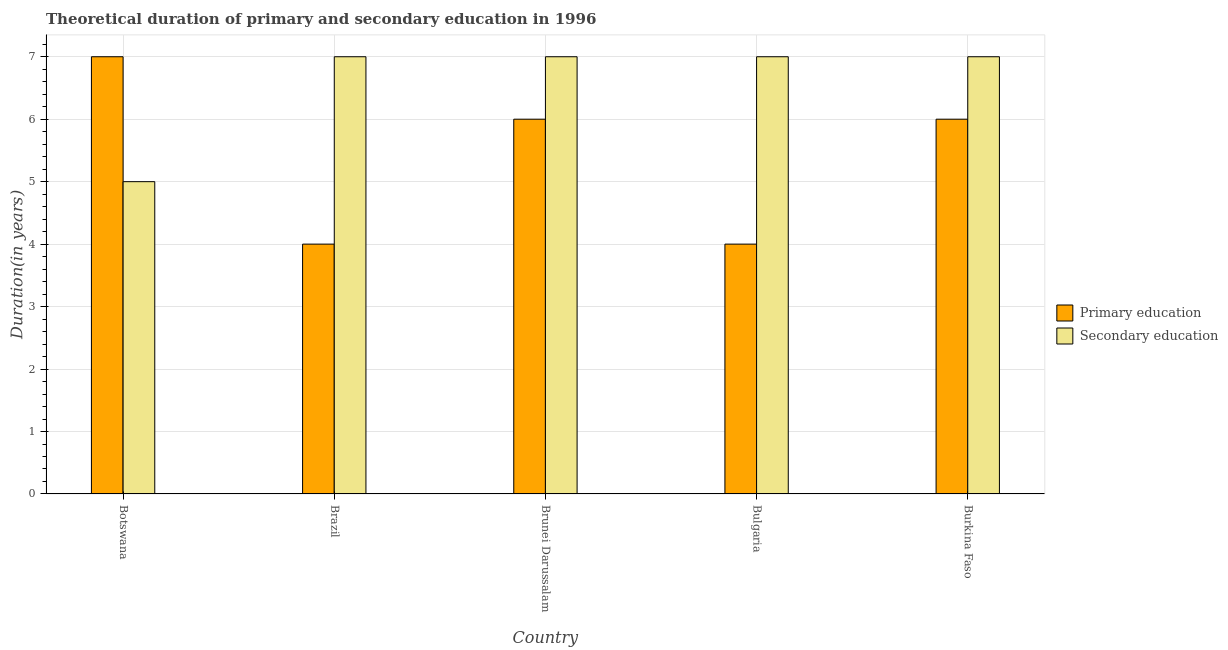How many different coloured bars are there?
Your answer should be compact. 2. How many groups of bars are there?
Ensure brevity in your answer.  5. Are the number of bars per tick equal to the number of legend labels?
Provide a succinct answer. Yes. How many bars are there on the 5th tick from the right?
Ensure brevity in your answer.  2. In how many cases, is the number of bars for a given country not equal to the number of legend labels?
Offer a very short reply. 0. What is the duration of primary education in Botswana?
Give a very brief answer. 7. Across all countries, what is the maximum duration of secondary education?
Ensure brevity in your answer.  7. Across all countries, what is the minimum duration of primary education?
Provide a short and direct response. 4. In which country was the duration of secondary education maximum?
Your answer should be very brief. Brazil. What is the total duration of secondary education in the graph?
Keep it short and to the point. 33. What is the difference between the duration of secondary education in Brazil and that in Bulgaria?
Make the answer very short. 0. What is the difference between the duration of primary education in Burkina Faso and the duration of secondary education in Bulgaria?
Your answer should be compact. -1. What is the average duration of secondary education per country?
Your answer should be compact. 6.6. What is the difference between the duration of secondary education and duration of primary education in Botswana?
Your response must be concise. -2. In how many countries, is the duration of secondary education greater than 1 years?
Your answer should be very brief. 5. What is the ratio of the duration of secondary education in Brunei Darussalam to that in Burkina Faso?
Provide a succinct answer. 1. What is the difference between the highest and the lowest duration of primary education?
Give a very brief answer. 3. Is the sum of the duration of primary education in Brazil and Brunei Darussalam greater than the maximum duration of secondary education across all countries?
Make the answer very short. Yes. What does the 2nd bar from the left in Brunei Darussalam represents?
Provide a short and direct response. Secondary education. What does the 1st bar from the right in Brunei Darussalam represents?
Make the answer very short. Secondary education. What is the difference between two consecutive major ticks on the Y-axis?
Offer a very short reply. 1. Are the values on the major ticks of Y-axis written in scientific E-notation?
Ensure brevity in your answer.  No. What is the title of the graph?
Offer a terse response. Theoretical duration of primary and secondary education in 1996. What is the label or title of the X-axis?
Your response must be concise. Country. What is the label or title of the Y-axis?
Provide a succinct answer. Duration(in years). What is the Duration(in years) of Primary education in Botswana?
Provide a short and direct response. 7. What is the Duration(in years) in Primary education in Brunei Darussalam?
Give a very brief answer. 6. What is the Duration(in years) of Primary education in Bulgaria?
Give a very brief answer. 4. What is the Duration(in years) in Primary education in Burkina Faso?
Offer a terse response. 6. What is the Duration(in years) of Secondary education in Burkina Faso?
Provide a succinct answer. 7. Across all countries, what is the minimum Duration(in years) in Primary education?
Your answer should be very brief. 4. What is the difference between the Duration(in years) of Primary education in Botswana and that in Brazil?
Give a very brief answer. 3. What is the difference between the Duration(in years) in Primary education in Botswana and that in Brunei Darussalam?
Offer a very short reply. 1. What is the difference between the Duration(in years) of Secondary education in Botswana and that in Bulgaria?
Provide a short and direct response. -2. What is the difference between the Duration(in years) of Secondary education in Botswana and that in Burkina Faso?
Your answer should be very brief. -2. What is the difference between the Duration(in years) in Primary education in Brazil and that in Brunei Darussalam?
Provide a succinct answer. -2. What is the difference between the Duration(in years) of Secondary education in Brazil and that in Brunei Darussalam?
Keep it short and to the point. 0. What is the difference between the Duration(in years) of Primary education in Brazil and that in Bulgaria?
Your answer should be compact. 0. What is the difference between the Duration(in years) in Secondary education in Brazil and that in Bulgaria?
Provide a short and direct response. 0. What is the difference between the Duration(in years) in Primary education in Brunei Darussalam and that in Burkina Faso?
Your answer should be compact. 0. What is the difference between the Duration(in years) in Secondary education in Brunei Darussalam and that in Burkina Faso?
Your response must be concise. 0. What is the difference between the Duration(in years) of Primary education in Brazil and the Duration(in years) of Secondary education in Brunei Darussalam?
Ensure brevity in your answer.  -3. What is the difference between the Duration(in years) in Primary education in Brazil and the Duration(in years) in Secondary education in Bulgaria?
Keep it short and to the point. -3. What is the difference between the Duration(in years) of Primary education in Brazil and the Duration(in years) of Secondary education in Burkina Faso?
Make the answer very short. -3. What is the difference between the Duration(in years) of Primary education in Brunei Darussalam and the Duration(in years) of Secondary education in Bulgaria?
Your answer should be compact. -1. What is the average Duration(in years) in Primary education per country?
Your response must be concise. 5.4. What is the average Duration(in years) of Secondary education per country?
Ensure brevity in your answer.  6.6. What is the difference between the Duration(in years) in Primary education and Duration(in years) in Secondary education in Botswana?
Your answer should be compact. 2. What is the difference between the Duration(in years) in Primary education and Duration(in years) in Secondary education in Brunei Darussalam?
Make the answer very short. -1. What is the difference between the Duration(in years) of Primary education and Duration(in years) of Secondary education in Bulgaria?
Give a very brief answer. -3. What is the ratio of the Duration(in years) in Primary education in Botswana to that in Brazil?
Provide a short and direct response. 1.75. What is the ratio of the Duration(in years) in Secondary education in Botswana to that in Brazil?
Offer a terse response. 0.71. What is the ratio of the Duration(in years) of Primary education in Botswana to that in Brunei Darussalam?
Give a very brief answer. 1.17. What is the ratio of the Duration(in years) in Primary education in Botswana to that in Burkina Faso?
Offer a terse response. 1.17. What is the ratio of the Duration(in years) in Secondary education in Botswana to that in Burkina Faso?
Ensure brevity in your answer.  0.71. What is the ratio of the Duration(in years) in Secondary education in Brazil to that in Brunei Darussalam?
Ensure brevity in your answer.  1. What is the ratio of the Duration(in years) in Primary education in Brazil to that in Bulgaria?
Ensure brevity in your answer.  1. What is the ratio of the Duration(in years) in Primary education in Brazil to that in Burkina Faso?
Ensure brevity in your answer.  0.67. What is the ratio of the Duration(in years) of Primary education in Brunei Darussalam to that in Bulgaria?
Give a very brief answer. 1.5. What is the ratio of the Duration(in years) in Secondary education in Brunei Darussalam to that in Bulgaria?
Your answer should be compact. 1. What is the ratio of the Duration(in years) of Primary education in Brunei Darussalam to that in Burkina Faso?
Make the answer very short. 1. What is the ratio of the Duration(in years) of Secondary education in Brunei Darussalam to that in Burkina Faso?
Offer a very short reply. 1. What is the ratio of the Duration(in years) of Secondary education in Bulgaria to that in Burkina Faso?
Your answer should be compact. 1. What is the difference between the highest and the second highest Duration(in years) of Secondary education?
Your answer should be compact. 0. What is the difference between the highest and the lowest Duration(in years) in Primary education?
Ensure brevity in your answer.  3. 